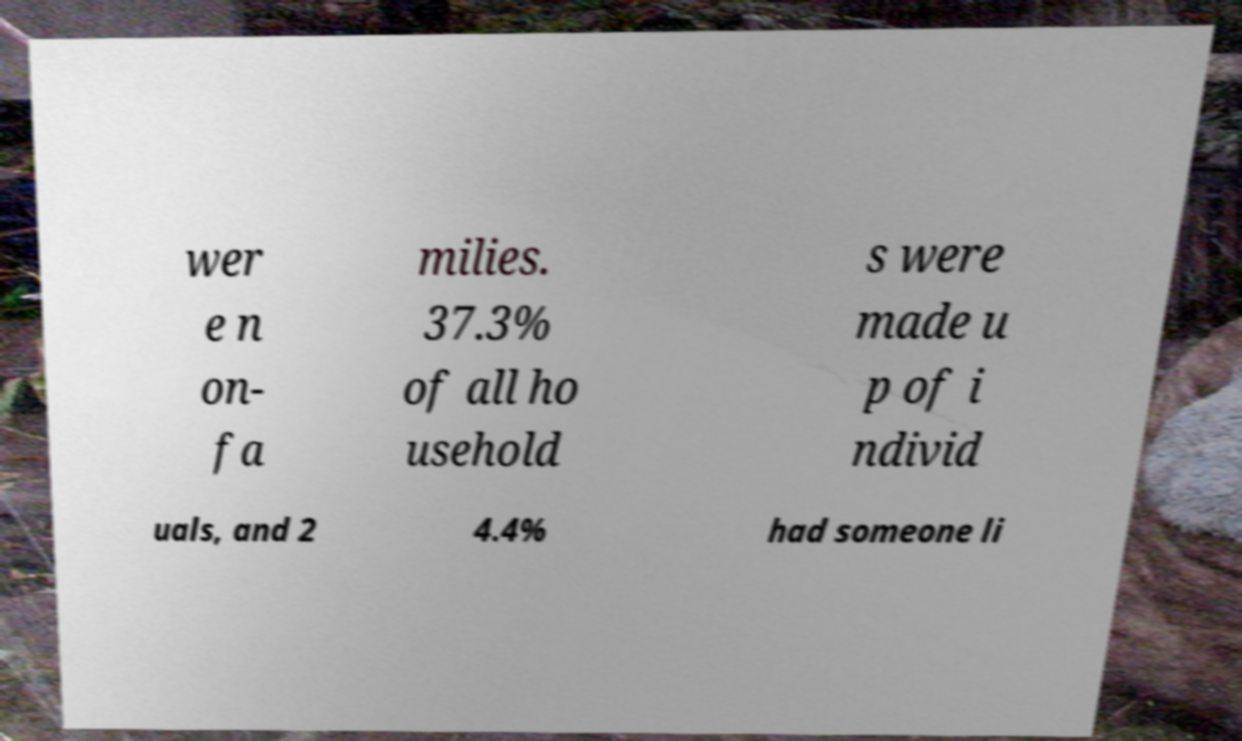Please identify and transcribe the text found in this image. wer e n on- fa milies. 37.3% of all ho usehold s were made u p of i ndivid uals, and 2 4.4% had someone li 